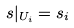<formula> <loc_0><loc_0><loc_500><loc_500>s | _ { U _ { i } } = s _ { i }</formula> 